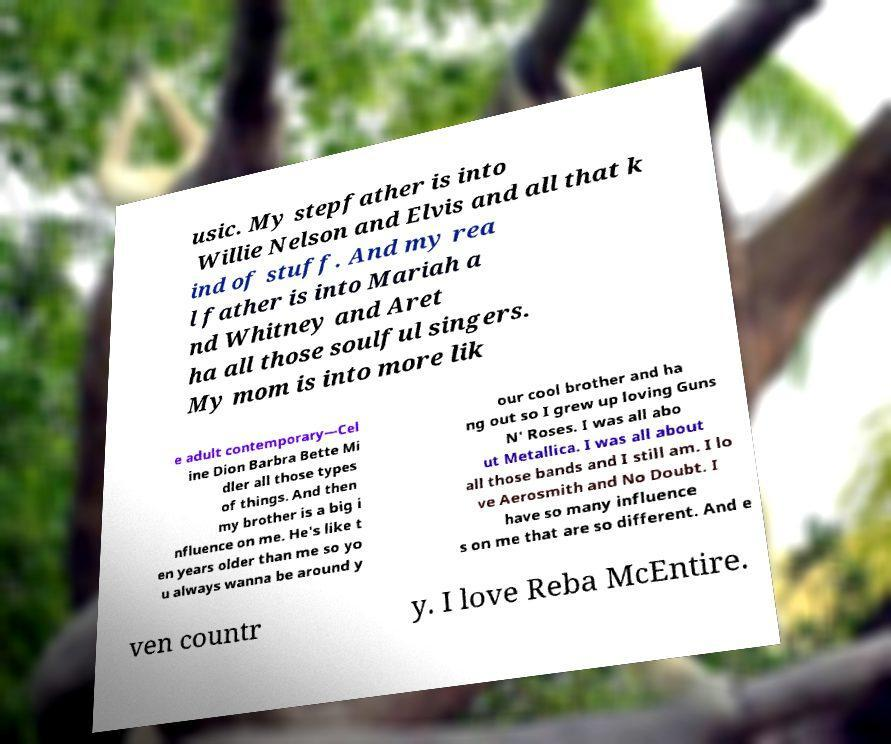Could you assist in decoding the text presented in this image and type it out clearly? usic. My stepfather is into Willie Nelson and Elvis and all that k ind of stuff. And my rea l father is into Mariah a nd Whitney and Aret ha all those soulful singers. My mom is into more lik e adult contemporary—Cel ine Dion Barbra Bette Mi dler all those types of things. And then my brother is a big i nfluence on me. He's like t en years older than me so yo u always wanna be around y our cool brother and ha ng out so I grew up loving Guns N' Roses. I was all abo ut Metallica. I was all about all those bands and I still am. I lo ve Aerosmith and No Doubt. I have so many influence s on me that are so different. And e ven countr y. I love Reba McEntire. 